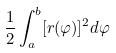<formula> <loc_0><loc_0><loc_500><loc_500>\frac { 1 } { 2 } \int _ { a } ^ { b } [ r ( \varphi ) ] ^ { 2 } d \varphi</formula> 